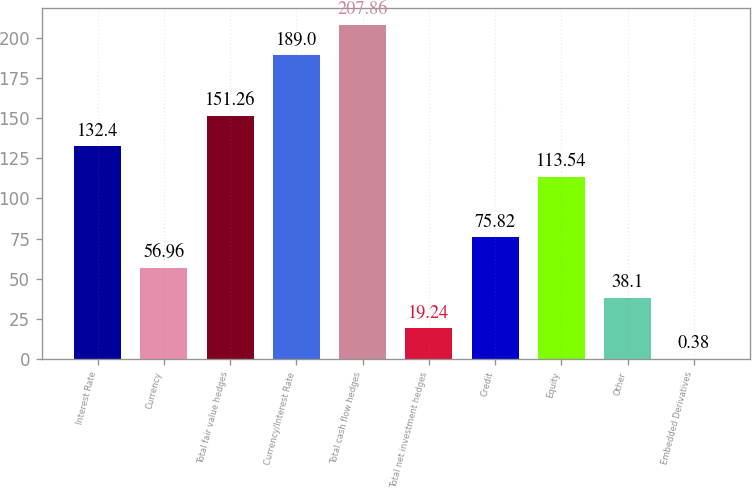Convert chart to OTSL. <chart><loc_0><loc_0><loc_500><loc_500><bar_chart><fcel>Interest Rate<fcel>Currency<fcel>Total fair value hedges<fcel>Currency/Interest Rate<fcel>Total cash flow hedges<fcel>Total net investment hedges<fcel>Credit<fcel>Equity<fcel>Other<fcel>Embedded Derivatives<nl><fcel>132.4<fcel>56.96<fcel>151.26<fcel>189<fcel>207.86<fcel>19.24<fcel>75.82<fcel>113.54<fcel>38.1<fcel>0.38<nl></chart> 